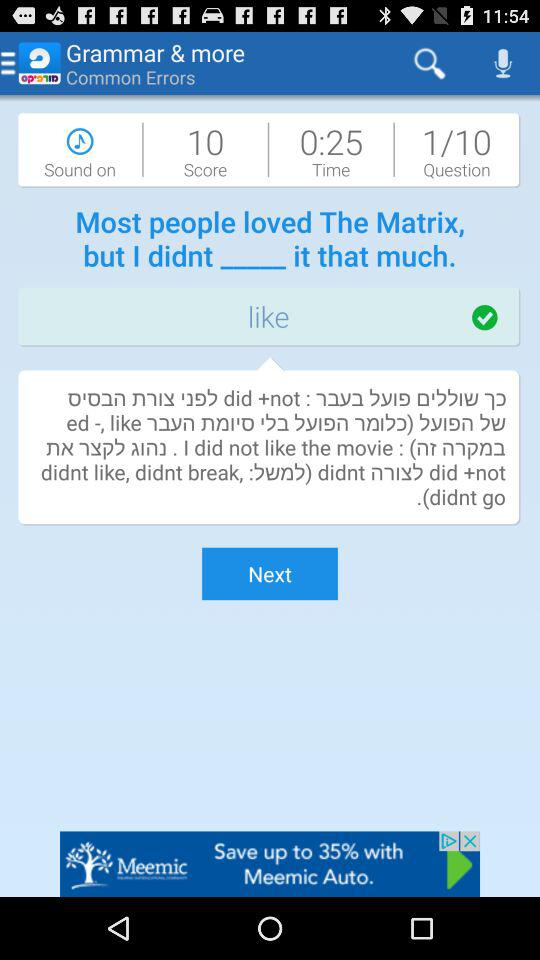What is the time? The time is 25 seconds. 